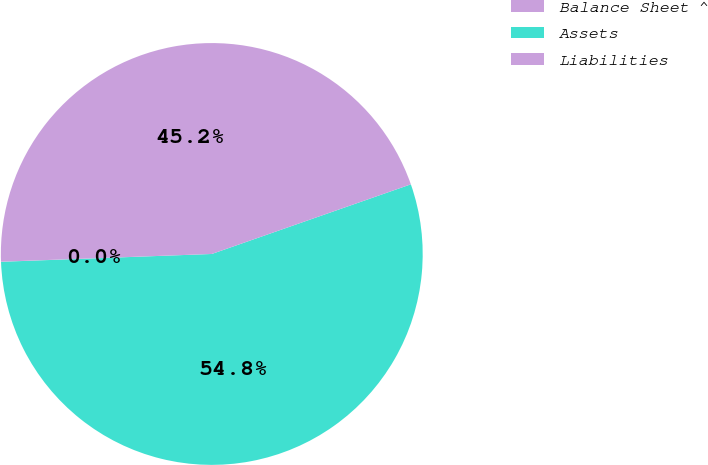Convert chart. <chart><loc_0><loc_0><loc_500><loc_500><pie_chart><fcel>Balance Sheet ^<fcel>Assets<fcel>Liabilities<nl><fcel>0.01%<fcel>54.77%<fcel>45.23%<nl></chart> 